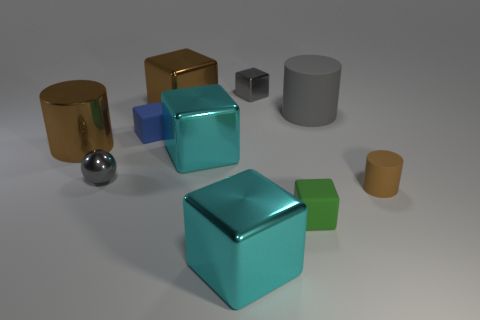There is a cylinder that is both on the right side of the small gray cube and in front of the small blue thing; what color is it?
Provide a short and direct response. Brown. Are there the same number of small blue rubber cubes that are on the right side of the tiny blue matte block and gray matte cylinders on the left side of the sphere?
Offer a terse response. Yes. What color is the large cylinder that is made of the same material as the small green object?
Your answer should be very brief. Gray. Does the metal sphere have the same color as the cylinder behind the big brown cylinder?
Keep it short and to the point. Yes. Are there any big cyan cubes that are to the left of the big cyan metal object that is in front of the small gray metal object to the left of the brown block?
Offer a very short reply. Yes. What is the shape of the large brown thing that is the same material as the big brown cylinder?
Provide a succinct answer. Cube. Are there any other things that have the same shape as the big rubber object?
Provide a short and direct response. Yes. What is the shape of the small brown object?
Offer a terse response. Cylinder. There is a small gray metal object to the right of the small ball; does it have the same shape as the big gray object?
Offer a terse response. No. Is the number of tiny gray metallic objects behind the brown metallic block greater than the number of big cyan objects that are behind the large gray rubber object?
Offer a terse response. Yes. 